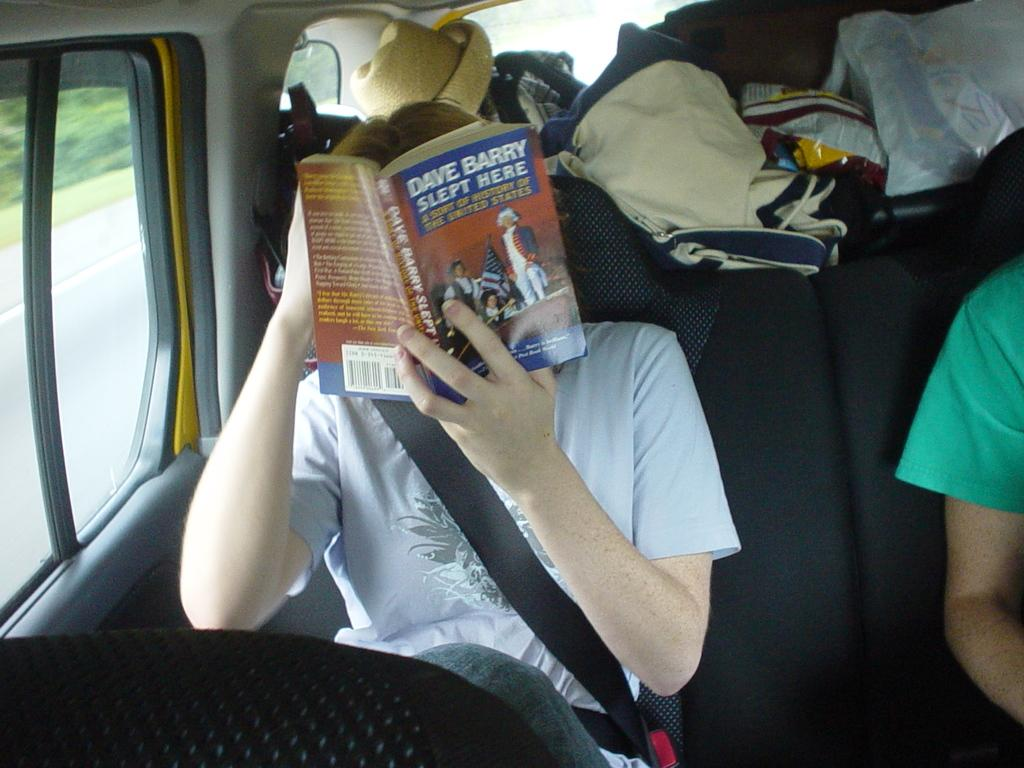Provide a one-sentence caption for the provided image. Davy Barry Slept Here Book is keeping this person busy on their journey. 